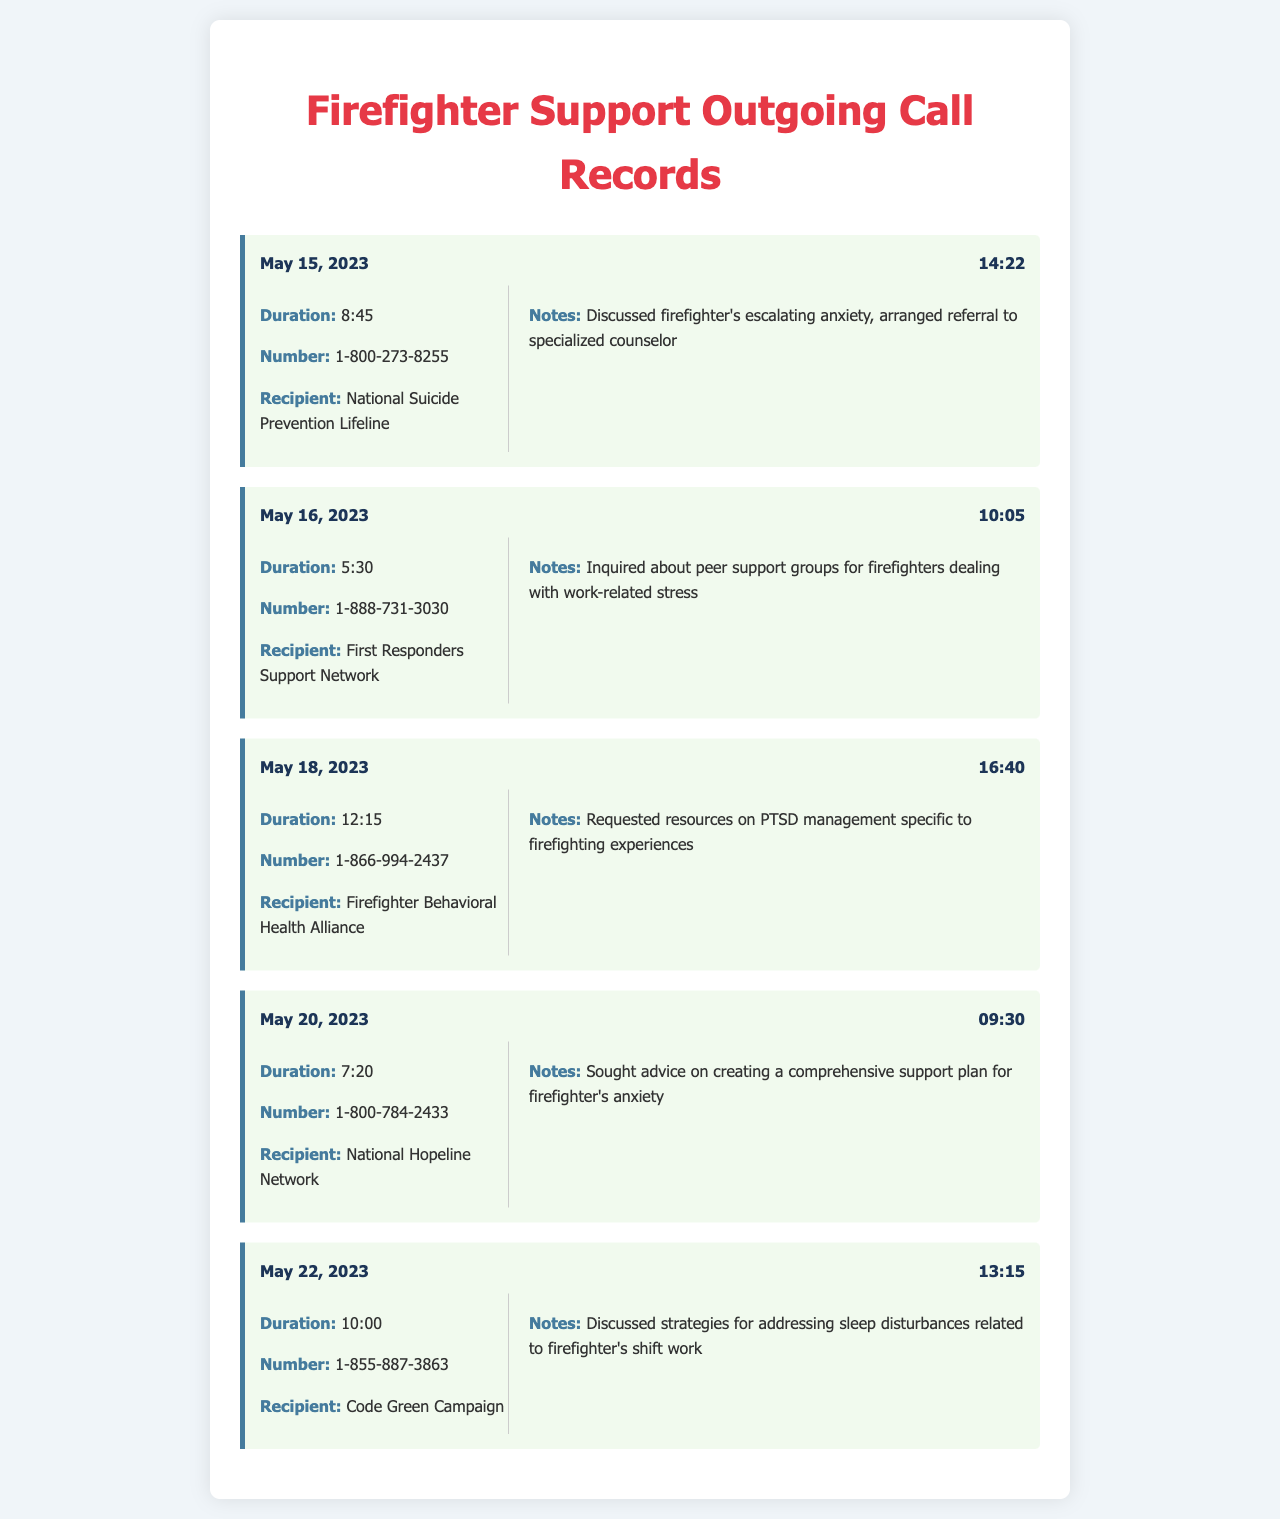what is the date of the first call? The date of the first call is mentioned at the beginning of the records.
Answer: May 15, 2023 what is the duration of the call made to the First Responders Support Network? The duration is specified in the call details for that call entry.
Answer: 5:30 what number was called on May 22, 2023? The number is listed in the call details for that specific date.
Answer: 1-855-887-3863 what support was discussed during the call to the Firefighter Behavioral Health Alliance? The notes section provides insight into the support discussed during that call.
Answer: Resources on PTSD management specific to firefighting experiences how long was the call with the National Suicide Prevention Lifeline? The duration of that call is provided in the details section of the first call record.
Answer: 8:45 which organization was contacted regarding strategies for sleep disturbances? The recipient of the call is listed in the call record on May 22, 2023.
Answer: Code Green Campaign how many calls were made between May 15 and May 22, 2023? The number of call records listed in the document represents the calls made during that period.
Answer: 5 what was the main topic of the call with the National Hopeline Network? The notes provide a summary of the advice sought during that call.
Answer: Creating a comprehensive support plan for firefighter's anxiety which recipient received the longest call duration? The call records indicate the duration associated with each call, allowing for comparison.
Answer: Firefighter Behavioral Health Alliance 